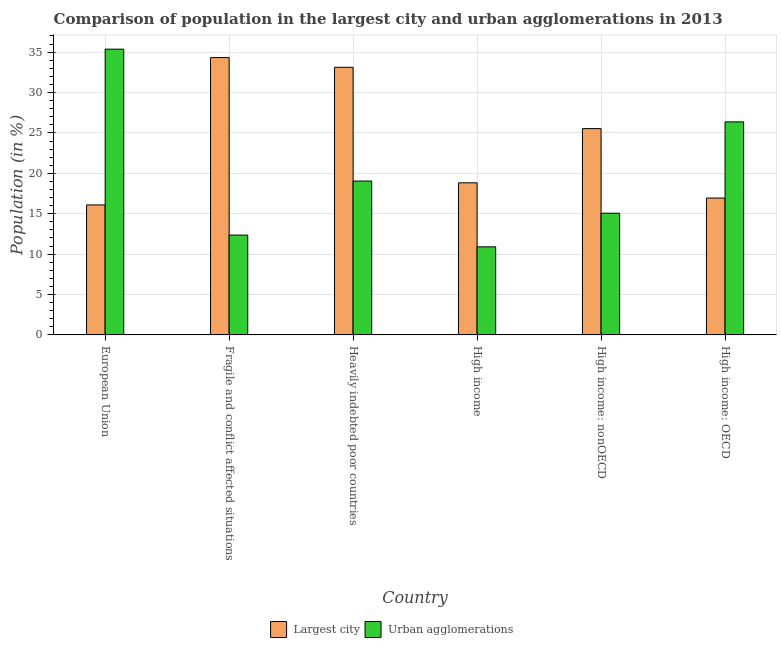How many groups of bars are there?
Your response must be concise. 6. Are the number of bars per tick equal to the number of legend labels?
Provide a succinct answer. Yes. How many bars are there on the 1st tick from the right?
Your answer should be very brief. 2. What is the label of the 4th group of bars from the left?
Your answer should be compact. High income. What is the population in the largest city in Heavily indebted poor countries?
Keep it short and to the point. 33.13. Across all countries, what is the maximum population in urban agglomerations?
Provide a succinct answer. 35.37. Across all countries, what is the minimum population in urban agglomerations?
Ensure brevity in your answer.  10.9. In which country was the population in the largest city maximum?
Provide a succinct answer. Fragile and conflict affected situations. What is the total population in the largest city in the graph?
Ensure brevity in your answer.  144.85. What is the difference between the population in the largest city in Fragile and conflict affected situations and that in Heavily indebted poor countries?
Make the answer very short. 1.2. What is the difference between the population in urban agglomerations in European Union and the population in the largest city in High income: nonOECD?
Offer a terse response. 9.83. What is the average population in the largest city per country?
Provide a short and direct response. 24.14. What is the difference between the population in urban agglomerations and population in the largest city in High income?
Ensure brevity in your answer.  -7.92. In how many countries, is the population in the largest city greater than 1 %?
Ensure brevity in your answer.  6. What is the ratio of the population in the largest city in High income: OECD to that in High income: nonOECD?
Provide a succinct answer. 0.66. What is the difference between the highest and the second highest population in the largest city?
Your answer should be very brief. 1.2. What is the difference between the highest and the lowest population in the largest city?
Provide a short and direct response. 18.24. In how many countries, is the population in the largest city greater than the average population in the largest city taken over all countries?
Offer a terse response. 3. What does the 1st bar from the left in High income: OECD represents?
Make the answer very short. Largest city. What does the 1st bar from the right in High income: OECD represents?
Provide a short and direct response. Urban agglomerations. How many countries are there in the graph?
Offer a terse response. 6. Does the graph contain grids?
Offer a very short reply. Yes. Where does the legend appear in the graph?
Provide a succinct answer. Bottom center. How many legend labels are there?
Ensure brevity in your answer.  2. How are the legend labels stacked?
Your answer should be very brief. Horizontal. What is the title of the graph?
Keep it short and to the point. Comparison of population in the largest city and urban agglomerations in 2013. What is the label or title of the Y-axis?
Give a very brief answer. Population (in %). What is the Population (in %) of Largest city in European Union?
Offer a terse response. 16.09. What is the Population (in %) in Urban agglomerations in European Union?
Your response must be concise. 35.37. What is the Population (in %) of Largest city in Fragile and conflict affected situations?
Keep it short and to the point. 34.33. What is the Population (in %) of Urban agglomerations in Fragile and conflict affected situations?
Give a very brief answer. 12.36. What is the Population (in %) of Largest city in Heavily indebted poor countries?
Provide a succinct answer. 33.13. What is the Population (in %) of Urban agglomerations in Heavily indebted poor countries?
Offer a terse response. 19.04. What is the Population (in %) of Largest city in High income?
Your answer should be very brief. 18.83. What is the Population (in %) of Urban agglomerations in High income?
Ensure brevity in your answer.  10.9. What is the Population (in %) of Largest city in High income: nonOECD?
Your answer should be compact. 25.54. What is the Population (in %) of Urban agglomerations in High income: nonOECD?
Keep it short and to the point. 15.06. What is the Population (in %) of Largest city in High income: OECD?
Ensure brevity in your answer.  16.94. What is the Population (in %) of Urban agglomerations in High income: OECD?
Offer a very short reply. 26.37. Across all countries, what is the maximum Population (in %) in Largest city?
Keep it short and to the point. 34.33. Across all countries, what is the maximum Population (in %) of Urban agglomerations?
Offer a very short reply. 35.37. Across all countries, what is the minimum Population (in %) of Largest city?
Provide a succinct answer. 16.09. Across all countries, what is the minimum Population (in %) of Urban agglomerations?
Your answer should be compact. 10.9. What is the total Population (in %) of Largest city in the graph?
Make the answer very short. 144.85. What is the total Population (in %) in Urban agglomerations in the graph?
Make the answer very short. 119.11. What is the difference between the Population (in %) of Largest city in European Union and that in Fragile and conflict affected situations?
Offer a terse response. -18.24. What is the difference between the Population (in %) in Urban agglomerations in European Union and that in Fragile and conflict affected situations?
Your answer should be very brief. 23.01. What is the difference between the Population (in %) of Largest city in European Union and that in Heavily indebted poor countries?
Offer a very short reply. -17.04. What is the difference between the Population (in %) of Urban agglomerations in European Union and that in Heavily indebted poor countries?
Make the answer very short. 16.33. What is the difference between the Population (in %) in Largest city in European Union and that in High income?
Keep it short and to the point. -2.74. What is the difference between the Population (in %) of Urban agglomerations in European Union and that in High income?
Your answer should be compact. 24.47. What is the difference between the Population (in %) of Largest city in European Union and that in High income: nonOECD?
Provide a succinct answer. -9.45. What is the difference between the Population (in %) of Urban agglomerations in European Union and that in High income: nonOECD?
Your response must be concise. 20.31. What is the difference between the Population (in %) of Largest city in European Union and that in High income: OECD?
Offer a very short reply. -0.85. What is the difference between the Population (in %) in Urban agglomerations in European Union and that in High income: OECD?
Give a very brief answer. 9. What is the difference between the Population (in %) in Largest city in Fragile and conflict affected situations and that in Heavily indebted poor countries?
Keep it short and to the point. 1.2. What is the difference between the Population (in %) of Urban agglomerations in Fragile and conflict affected situations and that in Heavily indebted poor countries?
Ensure brevity in your answer.  -6.69. What is the difference between the Population (in %) of Largest city in Fragile and conflict affected situations and that in High income?
Your answer should be compact. 15.5. What is the difference between the Population (in %) in Urban agglomerations in Fragile and conflict affected situations and that in High income?
Your response must be concise. 1.46. What is the difference between the Population (in %) in Largest city in Fragile and conflict affected situations and that in High income: nonOECD?
Give a very brief answer. 8.79. What is the difference between the Population (in %) in Urban agglomerations in Fragile and conflict affected situations and that in High income: nonOECD?
Provide a succinct answer. -2.71. What is the difference between the Population (in %) of Largest city in Fragile and conflict affected situations and that in High income: OECD?
Keep it short and to the point. 17.39. What is the difference between the Population (in %) of Urban agglomerations in Fragile and conflict affected situations and that in High income: OECD?
Provide a short and direct response. -14.01. What is the difference between the Population (in %) in Largest city in Heavily indebted poor countries and that in High income?
Your response must be concise. 14.3. What is the difference between the Population (in %) of Urban agglomerations in Heavily indebted poor countries and that in High income?
Offer a very short reply. 8.14. What is the difference between the Population (in %) of Largest city in Heavily indebted poor countries and that in High income: nonOECD?
Provide a succinct answer. 7.59. What is the difference between the Population (in %) in Urban agglomerations in Heavily indebted poor countries and that in High income: nonOECD?
Keep it short and to the point. 3.98. What is the difference between the Population (in %) of Largest city in Heavily indebted poor countries and that in High income: OECD?
Provide a short and direct response. 16.18. What is the difference between the Population (in %) of Urban agglomerations in Heavily indebted poor countries and that in High income: OECD?
Provide a succinct answer. -7.33. What is the difference between the Population (in %) of Largest city in High income and that in High income: nonOECD?
Provide a short and direct response. -6.71. What is the difference between the Population (in %) of Urban agglomerations in High income and that in High income: nonOECD?
Your answer should be compact. -4.16. What is the difference between the Population (in %) in Largest city in High income and that in High income: OECD?
Offer a terse response. 1.88. What is the difference between the Population (in %) of Urban agglomerations in High income and that in High income: OECD?
Give a very brief answer. -15.47. What is the difference between the Population (in %) of Largest city in High income: nonOECD and that in High income: OECD?
Your answer should be compact. 8.59. What is the difference between the Population (in %) of Urban agglomerations in High income: nonOECD and that in High income: OECD?
Offer a terse response. -11.31. What is the difference between the Population (in %) of Largest city in European Union and the Population (in %) of Urban agglomerations in Fragile and conflict affected situations?
Offer a very short reply. 3.73. What is the difference between the Population (in %) of Largest city in European Union and the Population (in %) of Urban agglomerations in Heavily indebted poor countries?
Give a very brief answer. -2.95. What is the difference between the Population (in %) in Largest city in European Union and the Population (in %) in Urban agglomerations in High income?
Offer a terse response. 5.19. What is the difference between the Population (in %) in Largest city in European Union and the Population (in %) in Urban agglomerations in High income: nonOECD?
Make the answer very short. 1.03. What is the difference between the Population (in %) of Largest city in European Union and the Population (in %) of Urban agglomerations in High income: OECD?
Make the answer very short. -10.28. What is the difference between the Population (in %) in Largest city in Fragile and conflict affected situations and the Population (in %) in Urban agglomerations in Heavily indebted poor countries?
Offer a very short reply. 15.29. What is the difference between the Population (in %) of Largest city in Fragile and conflict affected situations and the Population (in %) of Urban agglomerations in High income?
Your response must be concise. 23.43. What is the difference between the Population (in %) in Largest city in Fragile and conflict affected situations and the Population (in %) in Urban agglomerations in High income: nonOECD?
Your answer should be very brief. 19.27. What is the difference between the Population (in %) of Largest city in Fragile and conflict affected situations and the Population (in %) of Urban agglomerations in High income: OECD?
Your answer should be compact. 7.96. What is the difference between the Population (in %) in Largest city in Heavily indebted poor countries and the Population (in %) in Urban agglomerations in High income?
Ensure brevity in your answer.  22.22. What is the difference between the Population (in %) of Largest city in Heavily indebted poor countries and the Population (in %) of Urban agglomerations in High income: nonOECD?
Ensure brevity in your answer.  18.06. What is the difference between the Population (in %) of Largest city in Heavily indebted poor countries and the Population (in %) of Urban agglomerations in High income: OECD?
Your response must be concise. 6.76. What is the difference between the Population (in %) of Largest city in High income and the Population (in %) of Urban agglomerations in High income: nonOECD?
Provide a short and direct response. 3.76. What is the difference between the Population (in %) of Largest city in High income and the Population (in %) of Urban agglomerations in High income: OECD?
Provide a short and direct response. -7.54. What is the difference between the Population (in %) in Largest city in High income: nonOECD and the Population (in %) in Urban agglomerations in High income: OECD?
Offer a very short reply. -0.83. What is the average Population (in %) of Largest city per country?
Give a very brief answer. 24.14. What is the average Population (in %) of Urban agglomerations per country?
Make the answer very short. 19.85. What is the difference between the Population (in %) of Largest city and Population (in %) of Urban agglomerations in European Union?
Make the answer very short. -19.28. What is the difference between the Population (in %) of Largest city and Population (in %) of Urban agglomerations in Fragile and conflict affected situations?
Your answer should be very brief. 21.97. What is the difference between the Population (in %) in Largest city and Population (in %) in Urban agglomerations in Heavily indebted poor countries?
Keep it short and to the point. 14.08. What is the difference between the Population (in %) in Largest city and Population (in %) in Urban agglomerations in High income?
Give a very brief answer. 7.92. What is the difference between the Population (in %) in Largest city and Population (in %) in Urban agglomerations in High income: nonOECD?
Give a very brief answer. 10.47. What is the difference between the Population (in %) of Largest city and Population (in %) of Urban agglomerations in High income: OECD?
Offer a very short reply. -9.43. What is the ratio of the Population (in %) of Largest city in European Union to that in Fragile and conflict affected situations?
Provide a short and direct response. 0.47. What is the ratio of the Population (in %) in Urban agglomerations in European Union to that in Fragile and conflict affected situations?
Your answer should be very brief. 2.86. What is the ratio of the Population (in %) of Largest city in European Union to that in Heavily indebted poor countries?
Give a very brief answer. 0.49. What is the ratio of the Population (in %) of Urban agglomerations in European Union to that in Heavily indebted poor countries?
Ensure brevity in your answer.  1.86. What is the ratio of the Population (in %) of Largest city in European Union to that in High income?
Keep it short and to the point. 0.85. What is the ratio of the Population (in %) in Urban agglomerations in European Union to that in High income?
Ensure brevity in your answer.  3.24. What is the ratio of the Population (in %) of Largest city in European Union to that in High income: nonOECD?
Offer a terse response. 0.63. What is the ratio of the Population (in %) in Urban agglomerations in European Union to that in High income: nonOECD?
Your answer should be compact. 2.35. What is the ratio of the Population (in %) in Largest city in European Union to that in High income: OECD?
Give a very brief answer. 0.95. What is the ratio of the Population (in %) in Urban agglomerations in European Union to that in High income: OECD?
Make the answer very short. 1.34. What is the ratio of the Population (in %) in Largest city in Fragile and conflict affected situations to that in Heavily indebted poor countries?
Keep it short and to the point. 1.04. What is the ratio of the Population (in %) of Urban agglomerations in Fragile and conflict affected situations to that in Heavily indebted poor countries?
Your response must be concise. 0.65. What is the ratio of the Population (in %) in Largest city in Fragile and conflict affected situations to that in High income?
Provide a succinct answer. 1.82. What is the ratio of the Population (in %) of Urban agglomerations in Fragile and conflict affected situations to that in High income?
Ensure brevity in your answer.  1.13. What is the ratio of the Population (in %) in Largest city in Fragile and conflict affected situations to that in High income: nonOECD?
Keep it short and to the point. 1.34. What is the ratio of the Population (in %) in Urban agglomerations in Fragile and conflict affected situations to that in High income: nonOECD?
Your answer should be very brief. 0.82. What is the ratio of the Population (in %) in Largest city in Fragile and conflict affected situations to that in High income: OECD?
Your answer should be very brief. 2.03. What is the ratio of the Population (in %) in Urban agglomerations in Fragile and conflict affected situations to that in High income: OECD?
Provide a short and direct response. 0.47. What is the ratio of the Population (in %) of Largest city in Heavily indebted poor countries to that in High income?
Make the answer very short. 1.76. What is the ratio of the Population (in %) of Urban agglomerations in Heavily indebted poor countries to that in High income?
Give a very brief answer. 1.75. What is the ratio of the Population (in %) in Largest city in Heavily indebted poor countries to that in High income: nonOECD?
Provide a succinct answer. 1.3. What is the ratio of the Population (in %) of Urban agglomerations in Heavily indebted poor countries to that in High income: nonOECD?
Provide a succinct answer. 1.26. What is the ratio of the Population (in %) of Largest city in Heavily indebted poor countries to that in High income: OECD?
Give a very brief answer. 1.96. What is the ratio of the Population (in %) in Urban agglomerations in Heavily indebted poor countries to that in High income: OECD?
Make the answer very short. 0.72. What is the ratio of the Population (in %) in Largest city in High income to that in High income: nonOECD?
Keep it short and to the point. 0.74. What is the ratio of the Population (in %) in Urban agglomerations in High income to that in High income: nonOECD?
Provide a short and direct response. 0.72. What is the ratio of the Population (in %) of Largest city in High income to that in High income: OECD?
Provide a short and direct response. 1.11. What is the ratio of the Population (in %) of Urban agglomerations in High income to that in High income: OECD?
Ensure brevity in your answer.  0.41. What is the ratio of the Population (in %) of Largest city in High income: nonOECD to that in High income: OECD?
Offer a terse response. 1.51. What is the ratio of the Population (in %) of Urban agglomerations in High income: nonOECD to that in High income: OECD?
Keep it short and to the point. 0.57. What is the difference between the highest and the second highest Population (in %) of Largest city?
Give a very brief answer. 1.2. What is the difference between the highest and the second highest Population (in %) in Urban agglomerations?
Make the answer very short. 9. What is the difference between the highest and the lowest Population (in %) of Largest city?
Ensure brevity in your answer.  18.24. What is the difference between the highest and the lowest Population (in %) in Urban agglomerations?
Offer a very short reply. 24.47. 